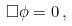Convert formula to latex. <formula><loc_0><loc_0><loc_500><loc_500>\square \phi = 0 \, ,</formula> 